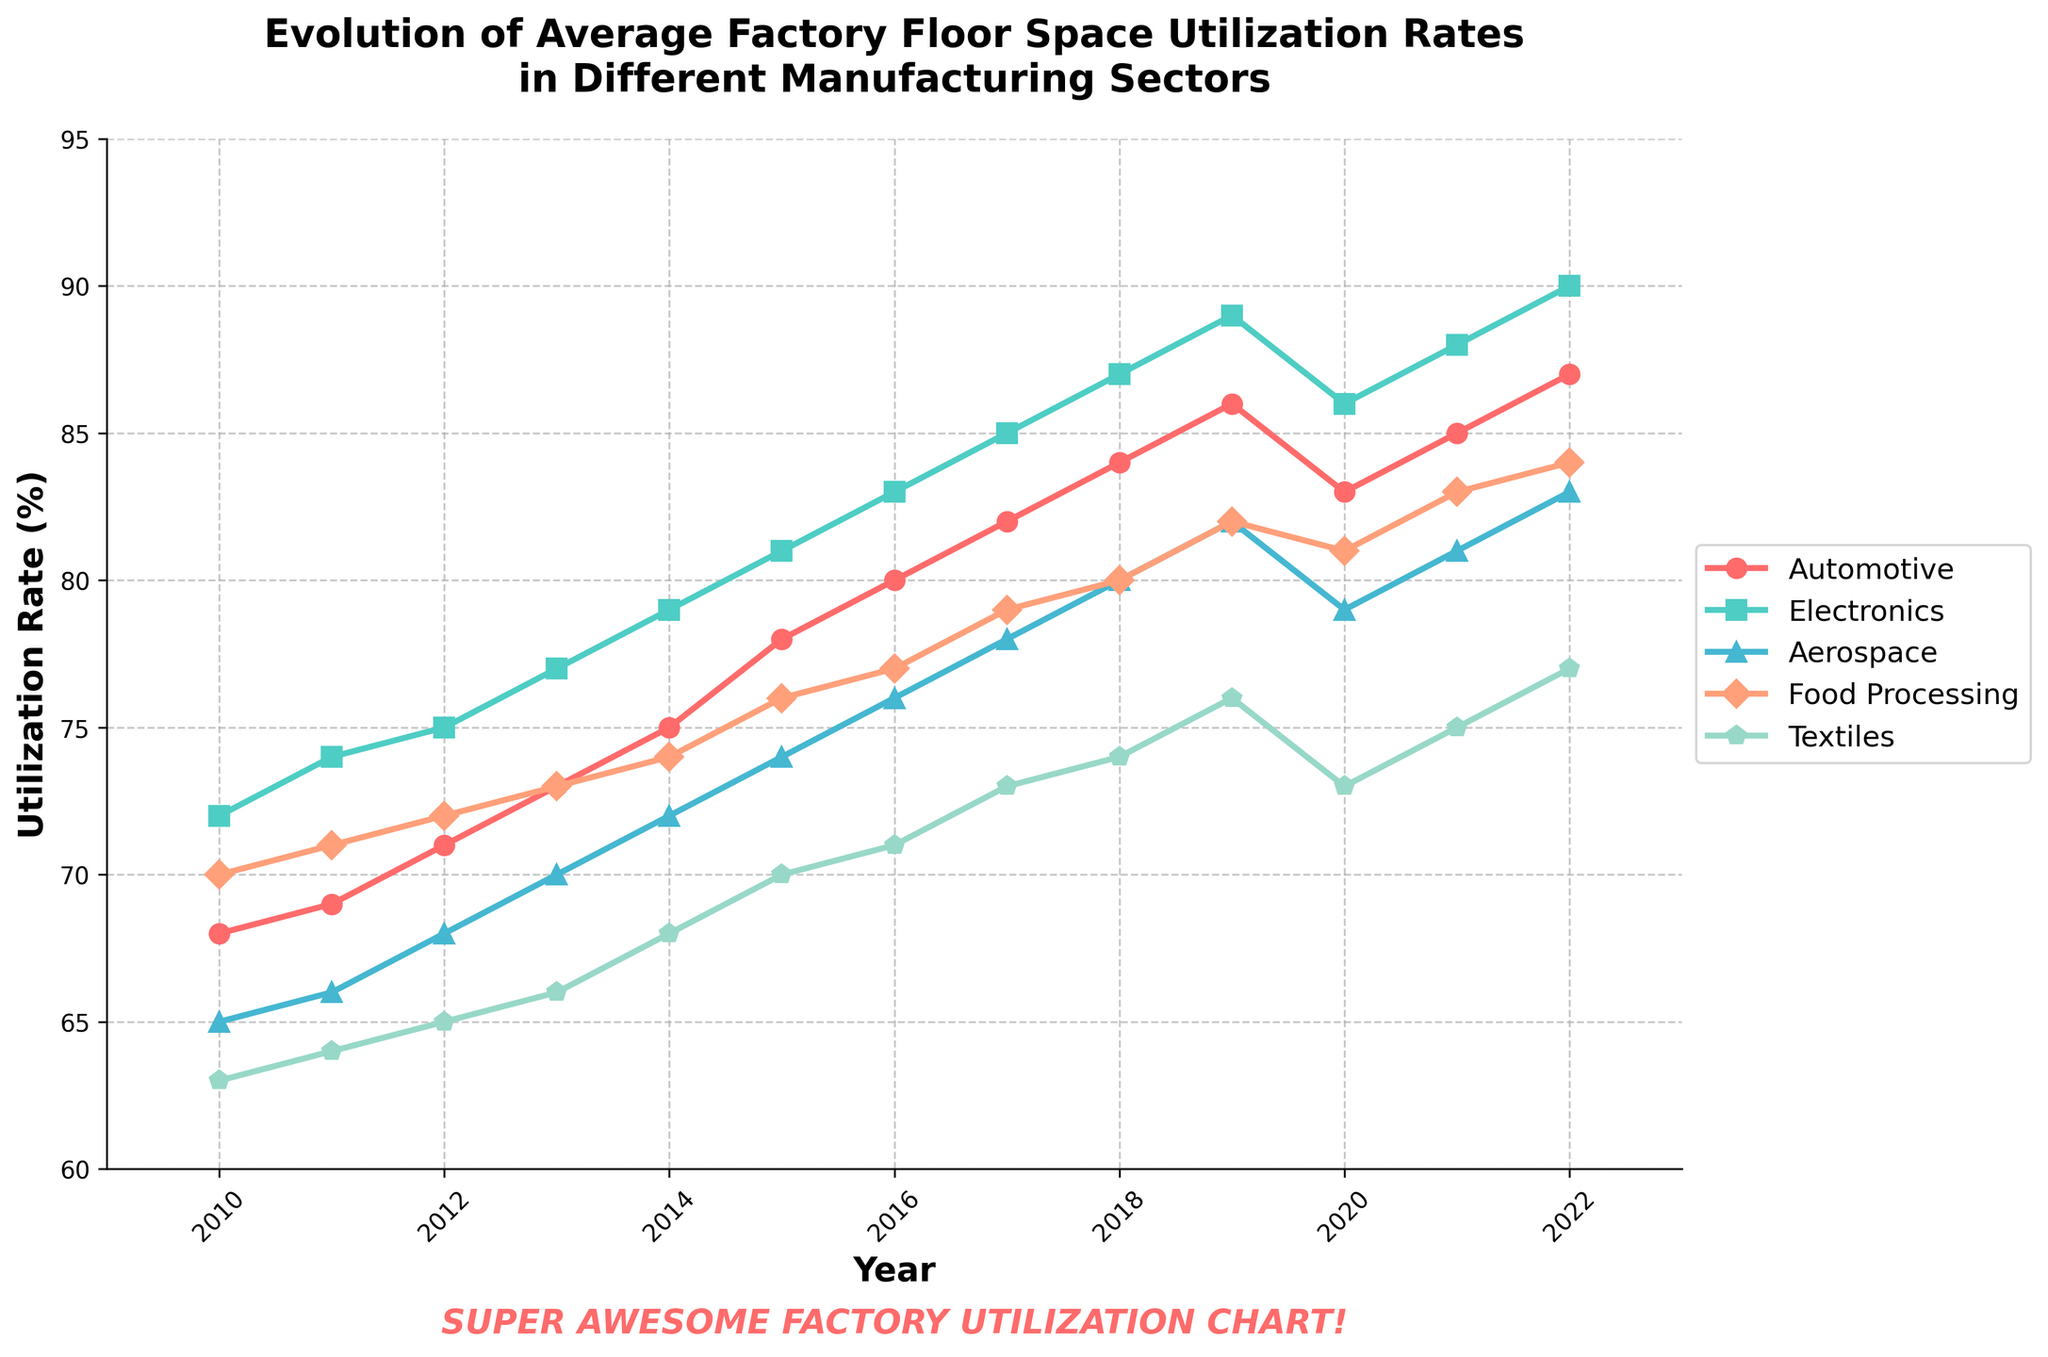What year did the Automotive sector first surpass an 80% utilization rate? To find this, look at the Automotive line on the chart and identify the first year it crosses above the 80% mark. This occurs in 2016.
Answer: 2016 Which sector had the highest utilization rate in 2022? Check the chart for the year 2022 and compare the utilization rates of all sectors. The Electronics sector has the highest utilization rate at 90%.
Answer: Electronics Between 2010 and 2022, which sector experienced the largest increase in utilization rate? Calculate the difference in utilization rate for each sector between 2010 and 2022. Automotive increased by 19% (87-68), Electronics by 18% (90-72), Aerospace by 18% (83-65), Food Processing by 14% (84-70), and Textiles by 14% (77-63). Thus, Automotive experienced the largest increase.
Answer: Automotive In which year did the Food Processing sector surpass the Textiles sector in utilization rate? Look for the point where the Food Processing line crosses above the Textiles line. This occurs in 2012.
Answer: 2012 Was there any sector that experienced a decline in utilization rate from 2019 to 2020? Compare the utilization rates of all sectors between 2019 and 2020. The Automotive sector dropped from 86% to 83% and the Electronics sector from 89% to 86%.
Answer: Yes On average, how did the utilization rates of all sectors change from 2010 to 2022? Calculate the average change in utilization by subtracting the 2010 rates from the 2022 rates and averaging the result: [(87-68) + (90-72) + (83-65) + (84-70) + (77-63)] / 5 = [19 + 18 + 18 + 14 + 14] / 5 = 16.6%.
Answer: 16.6% Which two sectors had the closest utilization rates in 2020, and what were the rates? Compare the utilization rates of all sectors in 2020 and find the smallest difference. Food Processing and Electronics have the closest rates at 81% and 86%, respectively.
Answer: Food Processing and Electronics; 81% and 86% What is the maximum utilization rate observed for any sector during the period 2010 to 2022? Look at the highest point on the chart for all sectors. The Electronics sector reached a maximum utilization rate of 90% in 2022.
Answer: 90% Across the whole period, which sector showed the most consistent upward trend? Examine the smoothness and direction of each line. The Electronics sector shows a steady and consistent upward trend without any declines.
Answer: Electronics 